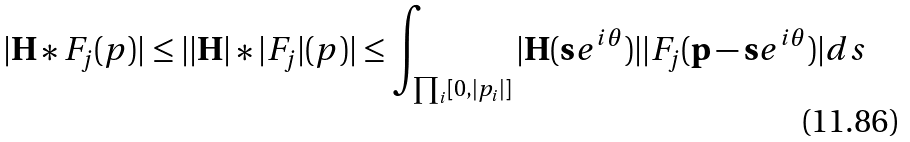<formula> <loc_0><loc_0><loc_500><loc_500>| \mathbf H * F _ { j } ( { p } ) | \leq | | \mathbf H | * | F _ { j } | ( { p } ) | \leq \int _ { \prod _ { i } [ 0 , | p _ { i } | ] } | \mathbf H ( \mathbf s e ^ { i \mathbf \theta } ) | | F _ { j } ( \mathbf p - \mathbf s e ^ { i \mathbf \theta } ) | d { s }</formula> 